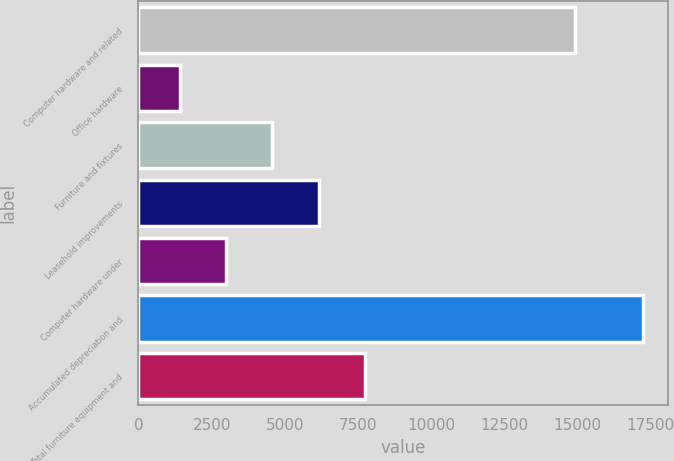<chart> <loc_0><loc_0><loc_500><loc_500><bar_chart><fcel>Computer hardware and related<fcel>Office hardware<fcel>Furniture and fixtures<fcel>Leasehold improvements<fcel>Computer hardware under<fcel>Accumulated depreciation and<fcel>Total furniture equipment and<nl><fcel>14932<fcel>1417<fcel>4578.6<fcel>6159.4<fcel>2997.8<fcel>17225<fcel>7740.2<nl></chart> 